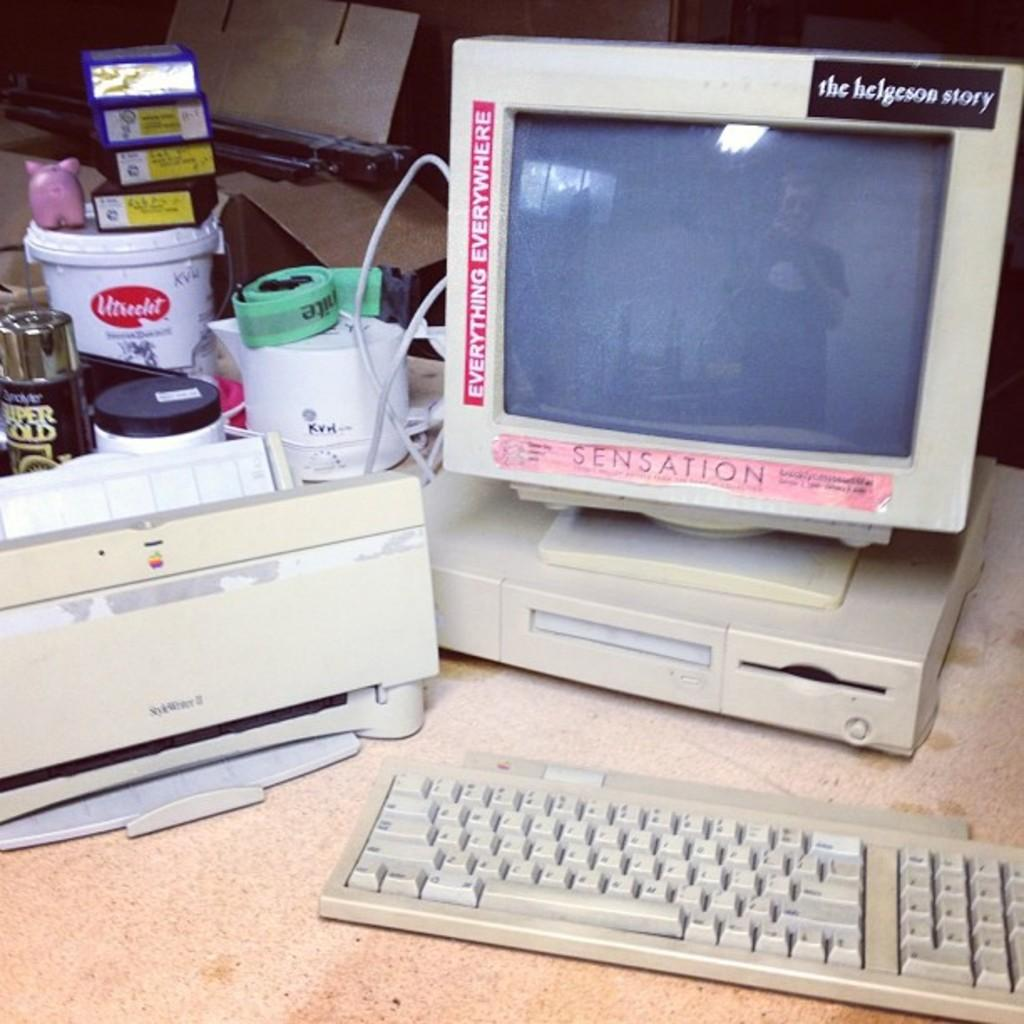<image>
Share a concise interpretation of the image provided. A computer monitor has stickers on it, one of which reads "everything everywhere." 